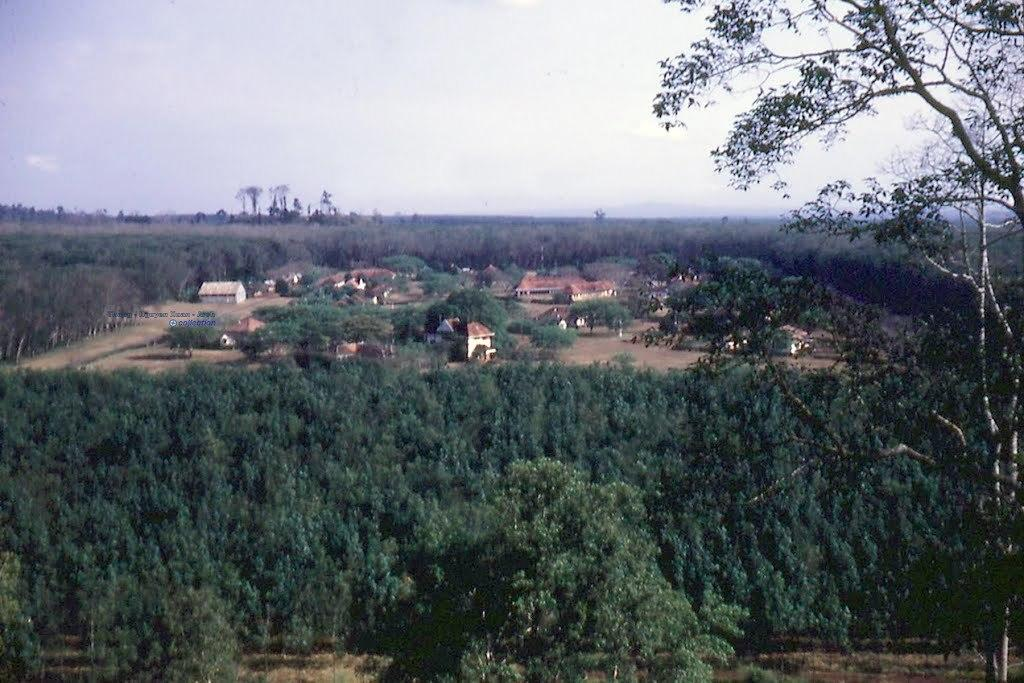What type of surface can be seen in the image? There is ground visible in the image. What type of vegetation is present in the image? There are trees in the image. What type of man-made structures are visible in the image? There are buildings in the image. What is visible in the background of the image? The sky is visible in the background of the image. What type of advice can be seen being given in the image? There is no advice being given in the image; it features ground, trees, buildings, and the sky. What type of wire is present in the image? There is no wire present in the image. 